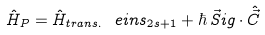<formula> <loc_0><loc_0><loc_500><loc_500>\hat { H } _ { P } = \hat { H } _ { t r a n s . } \ e i n s _ { 2 s + 1 } + \hbar { \, } \vec { S } i g \cdot \hat { \vec { C } }</formula> 